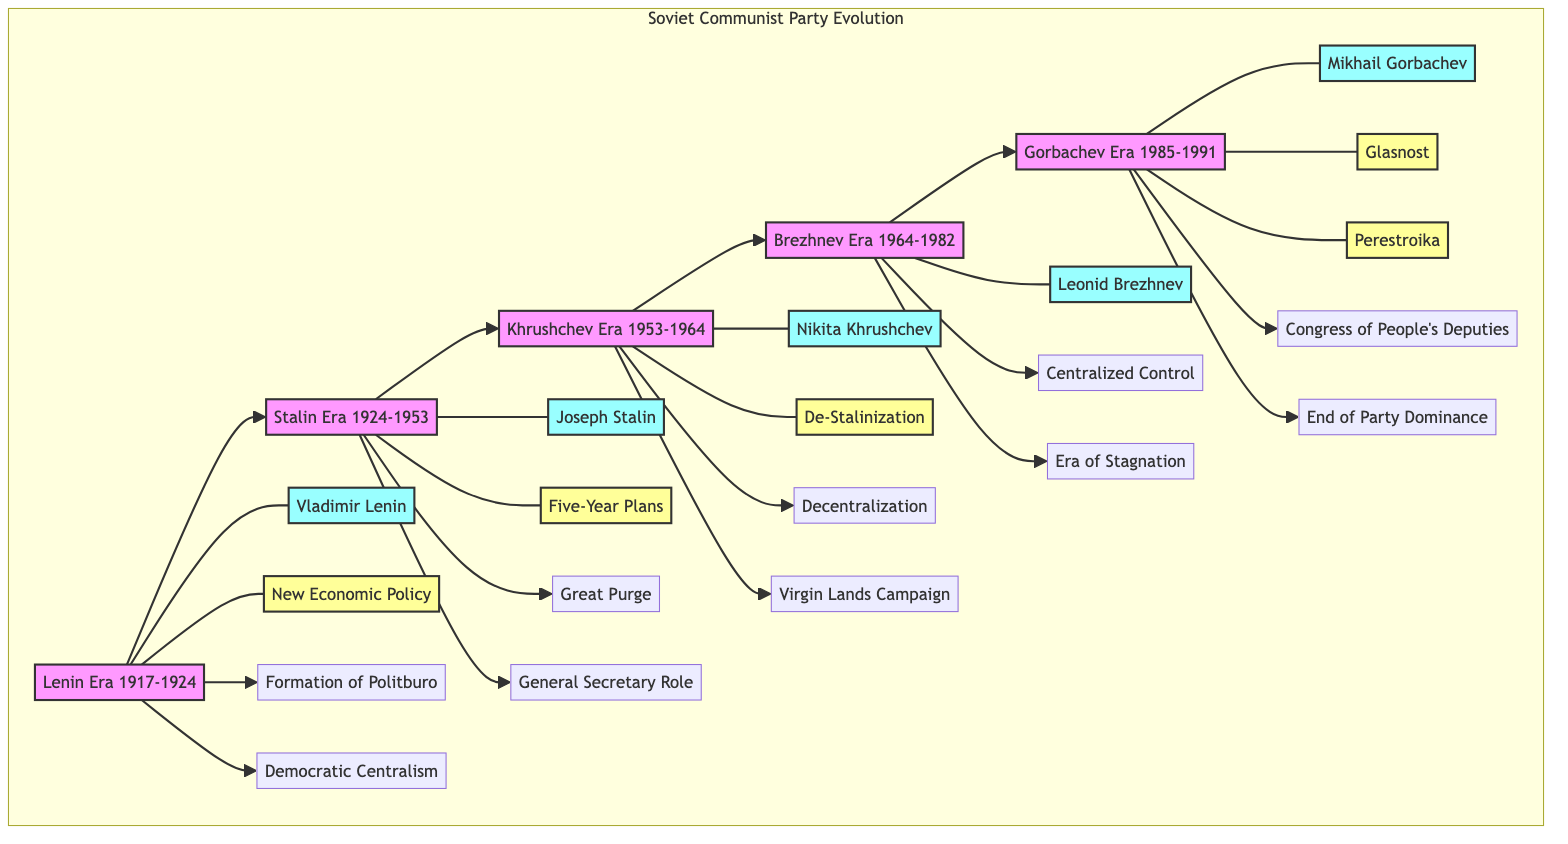What was the primary reform during the Lenin Era? According to the diagram, the reform labeled "New Economic Policy" is associated with the Lenin Era. It is linked directly to the node for the Lenin Era.
Answer: New Economic Policy Which leader's era immediately follows Stalin's? The diagram shows a linear progression across the eras, where Stalin Era (1924-1953) connects directly to Khrushchev Era (1953-1964). This indicates that Khrushchev's era follows Stalin's.
Answer: Khrushchev Era How many key elements are listed for the Gorbachev Era? The Gorbachev Era node has a direct connection to two key elements listed below it. Each of these lines indicates a key aspect of that era, confirming the count is two.
Answer: 2 What significant change is associated with the end of the Communist Party's dominance? Within the diagram, the final node linked to the Gorbachev Era indicates "End of the Communist Party's Dominance." This is a key feature of the specified era.
Answer: End of the Communist Party's Dominance Which leader is connected to the introduction of the Five-Year Plans? The diagram shows an arrow leading from the Stalin Era to the node labeled "Five-Year Plans." Therefore, it is evident that Joseph Stalin is the leader associated with this reform.
Answer: Joseph Stalin What was the general theme of the reforms introduced by Gorbachev? The Gorbachev Era is linked to two reforms, "Glasnost" and "Perestroika," both of which emphasize openness and restructuring, suggesting a theme of liberalization and reform.
Answer: Openness and restructuring What event is indicated as "Great Purge" during the Stalin Era? The node for the Stalin Era has a direct connection to the "Great Purge." This indicates its prominence as a significant event during that time, thus identifying what it was.
Answer: Great Purge Count the number of leaders listed in the diagram. The diagram includes five nodes specifically allocated for the leaders, each representing a prominent figure in the Soviet Communist Party hierarchy.
Answer: 5 Which two reforms are depicted during the Gorbachev Era? The Gorbachev Era node connects to two distinct reform nodes, "Glasnost" and "Perestroika." This directly shows the reforms introduced during this leader's time.
Answer: Glasnost and Perestroika 